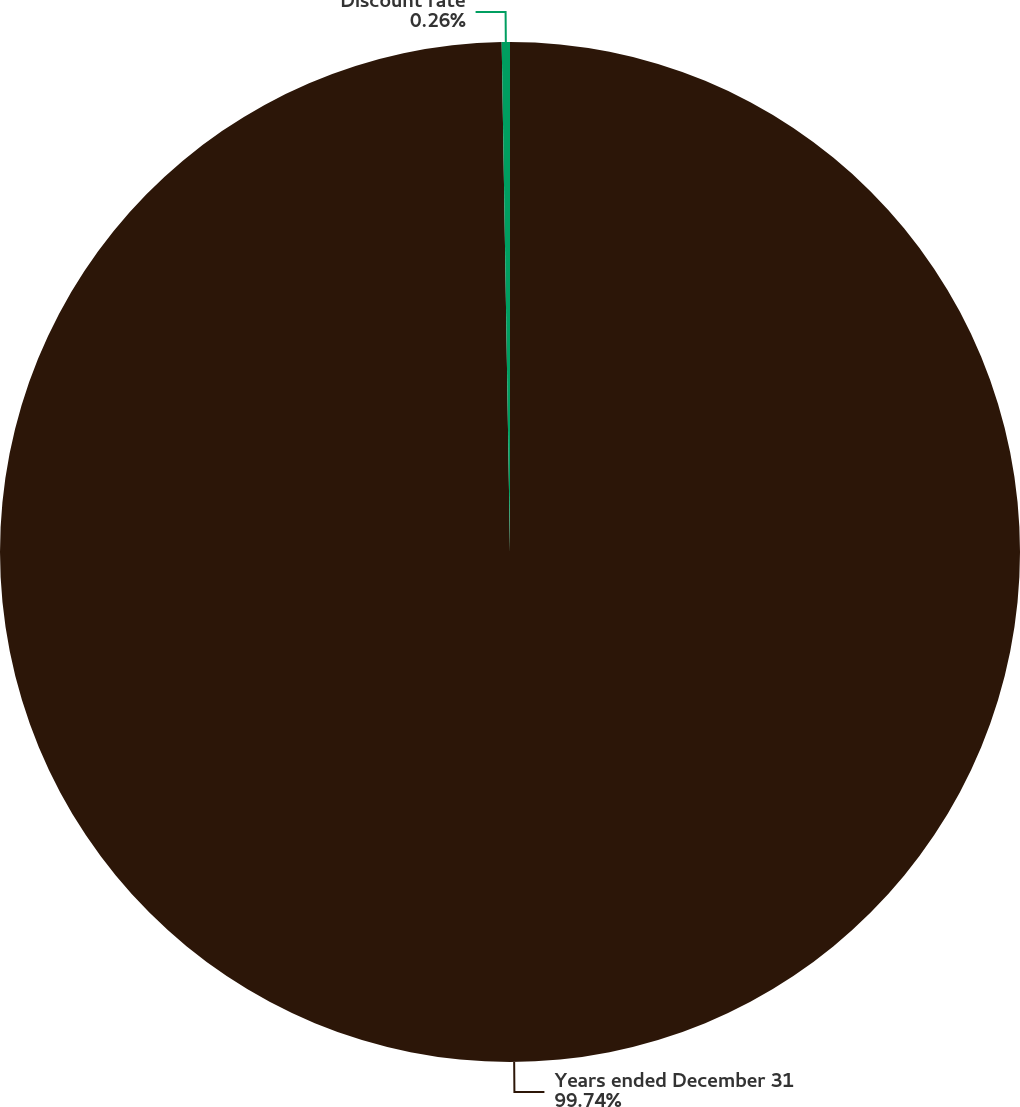<chart> <loc_0><loc_0><loc_500><loc_500><pie_chart><fcel>Years ended December 31<fcel>Discount rate<nl><fcel>99.74%<fcel>0.26%<nl></chart> 